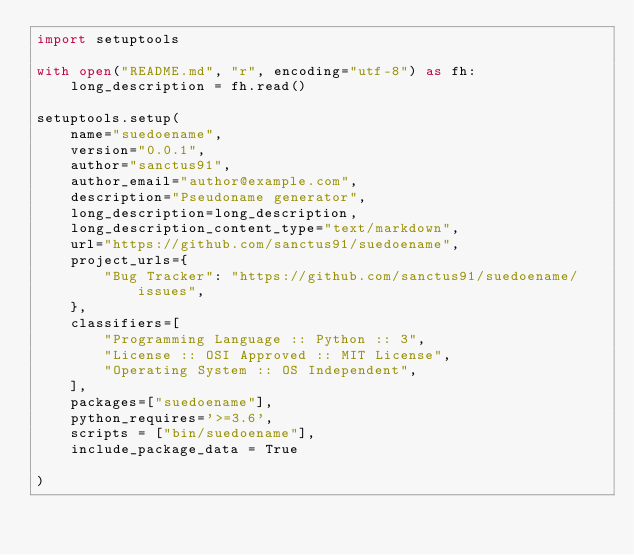<code> <loc_0><loc_0><loc_500><loc_500><_Python_>import setuptools

with open("README.md", "r", encoding="utf-8") as fh:
    long_description = fh.read()

setuptools.setup(
    name="suedoename", 
    version="0.0.1",
    author="sanctus91",
    author_email="author@example.com",
    description="Pseudoname generator",
    long_description=long_description,
    long_description_content_type="text/markdown",
    url="https://github.com/sanctus91/suedoename",
    project_urls={
        "Bug Tracker": "https://github.com/sanctus91/suedoename/issues",
    },
    classifiers=[
        "Programming Language :: Python :: 3",
        "License :: OSI Approved :: MIT License",
        "Operating System :: OS Independent",
    ],
    packages=["suedoename"],
    python_requires='>=3.6',
    scripts = ["bin/suedoename"],
    include_package_data = True

)

</code> 